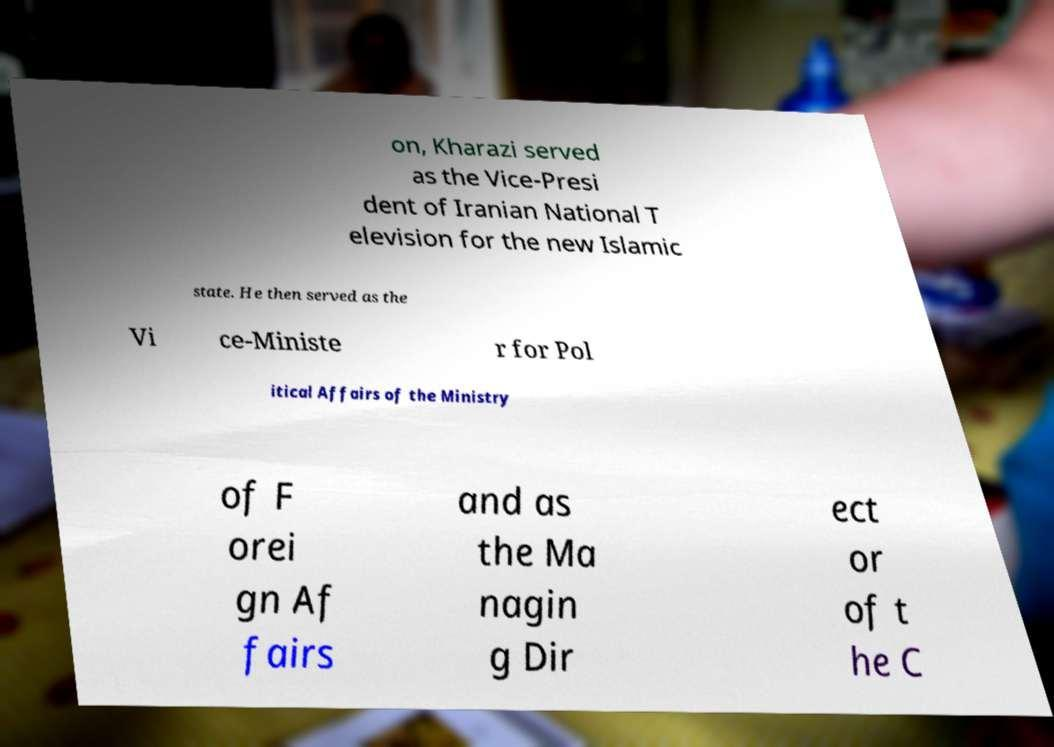Could you assist in decoding the text presented in this image and type it out clearly? on, Kharazi served as the Vice-Presi dent of Iranian National T elevision for the new Islamic state. He then served as the Vi ce-Ministe r for Pol itical Affairs of the Ministry of F orei gn Af fairs and as the Ma nagin g Dir ect or of t he C 